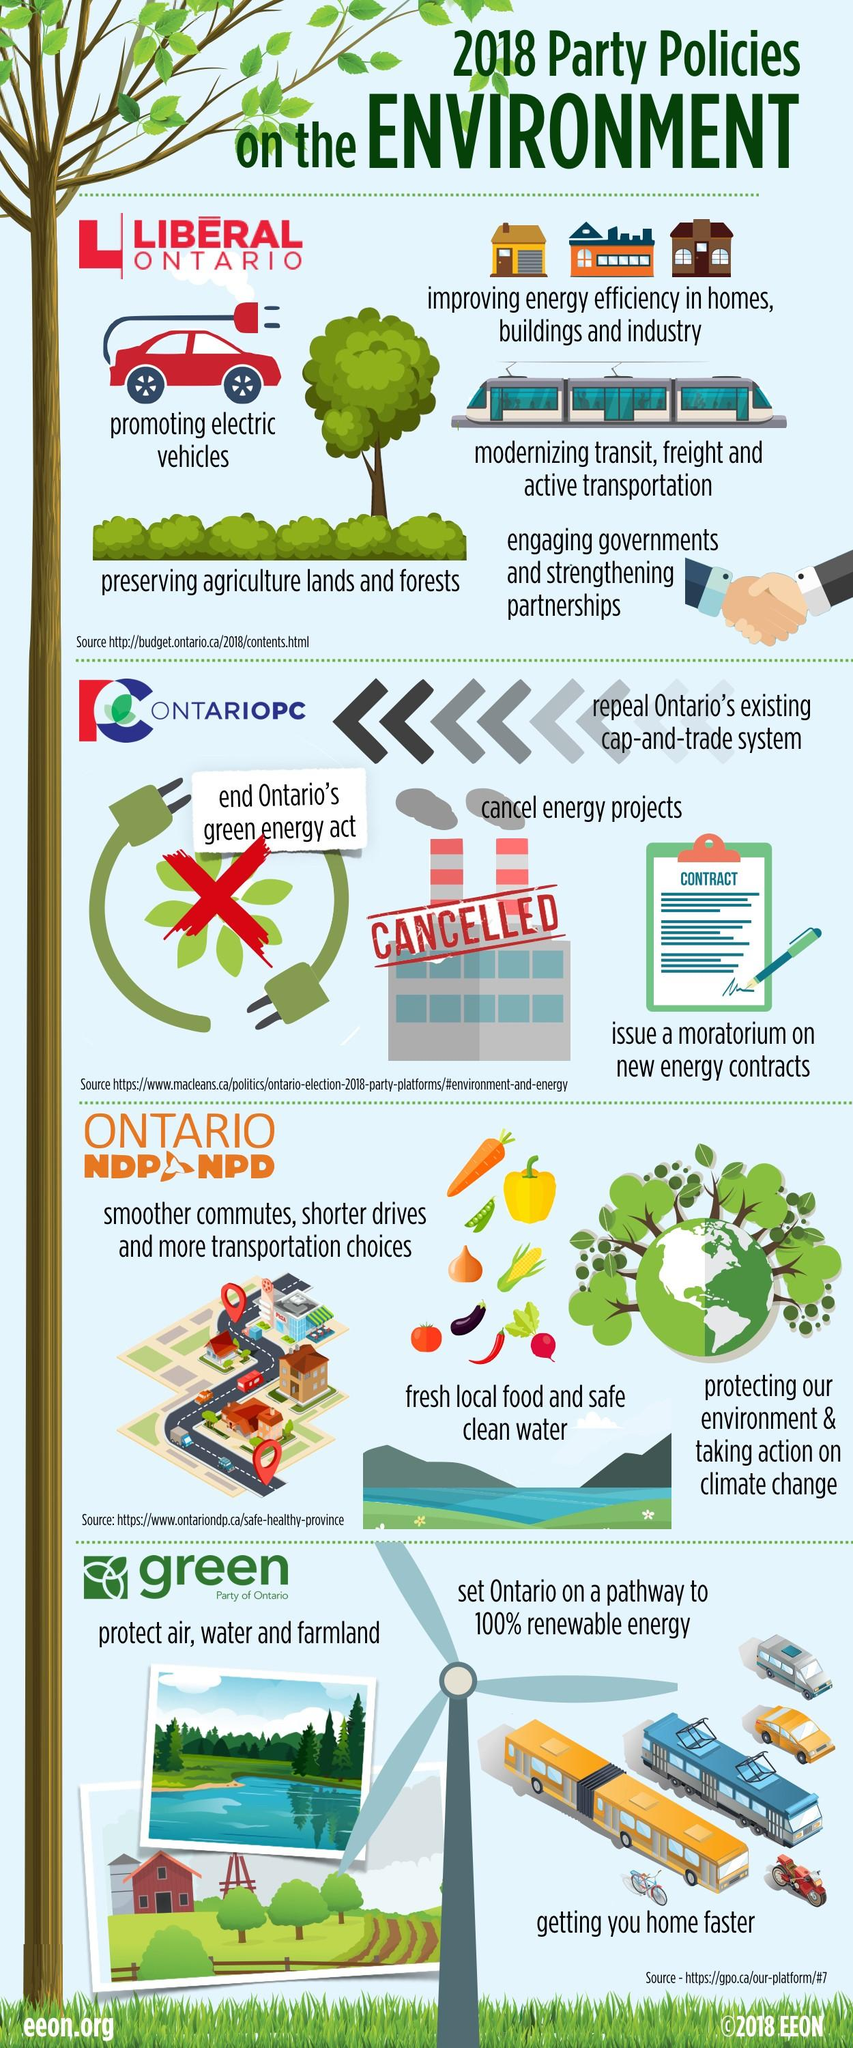Outline some significant characteristics in this image. On Wednesday, it was reported that the Ontario Court of Appeal had annulled several aspects of the province's carbon reduction efforts, including the Green Energy Act and energy projects. 